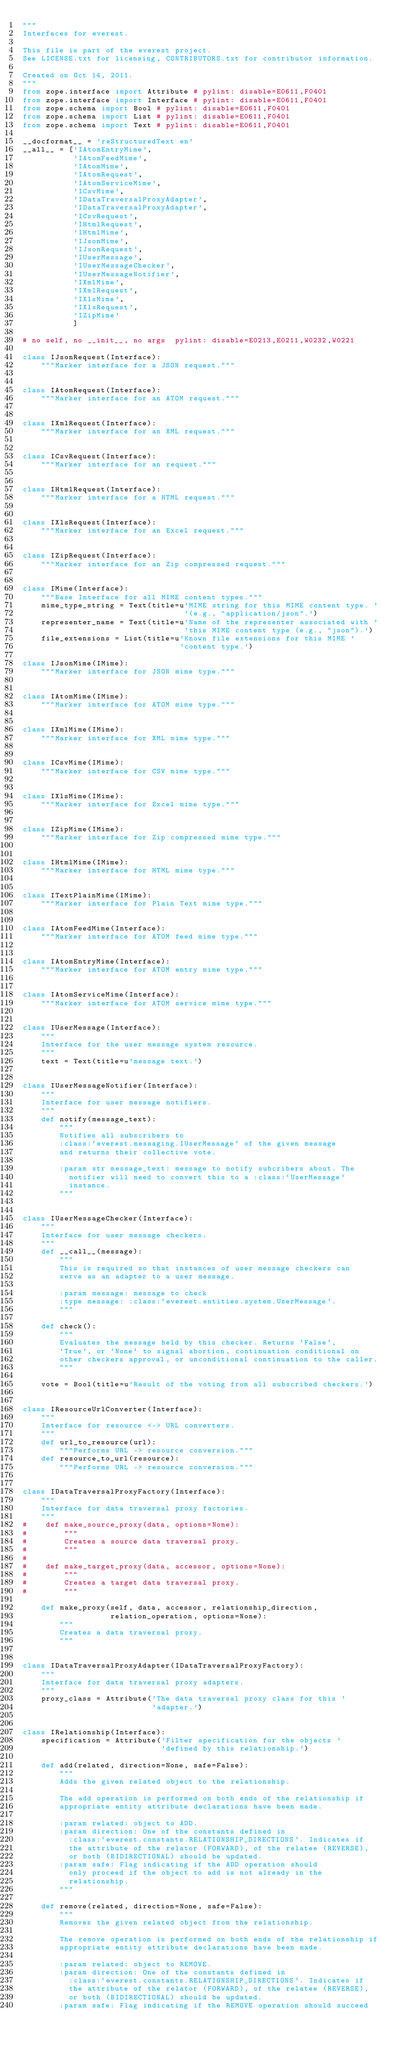<code> <loc_0><loc_0><loc_500><loc_500><_Python_>"""
Interfaces for everest.

This file is part of the everest project.
See LICENSE.txt for licensing, CONTRIBUTORS.txt for contributor information.

Created on Oct 14, 2011.
"""
from zope.interface import Attribute # pylint: disable=E0611,F0401
from zope.interface import Interface # pylint: disable=E0611,F0401
from zope.schema import Bool # pylint: disable=E0611,F0401
from zope.schema import List # pylint: disable=E0611,F0401
from zope.schema import Text # pylint: disable=E0611,F0401

__docformat__ = 'reStructuredText en'
__all__ = ['IAtomEntryMime',
           'IAtomFeedMime',
           'IAtomMime',
           'IAtomRequest',
           'IAtomServiceMime',
           'ICsvMime',
           'IDataTraversalProxyAdapter',
           'IDataTraversalProxyAdapter',
           'ICsvRequest',
           'IHtmlRequest',
           'IHtmlMime',
           'IJsonMime',
           'IJsonRequest',
           'IUserMessage',
           'IUserMessageChecker',
           'IUserMessageNotifier',
           'IXmlMime',
           'IXmlRequest',
           'IXlsMime',
           'IXlsRequest',
           'IZipMime'
           ]

# no self, no __init__, no args  pylint: disable=E0213,E0211,W0232,W0221

class IJsonRequest(Interface):
    """Marker interface for a JSON request."""


class IAtomRequest(Interface):
    """Marker interface for an ATOM request."""


class IXmlRequest(Interface):
    """Marker interface for an XML request."""


class ICsvRequest(Interface):
    """Marker interface for an request."""


class IHtmlRequest(Interface):
    """Marker interface for a HTML request."""


class IXlsRequest(Interface):
    """Marker interface for an Excel request."""


class IZipRequest(Interface):
    """Marker interface for an Zip compressed request."""


class IMime(Interface):
    """Base Interface for all MIME content types."""
    mime_type_string = Text(title=u'MIME string for this MIME content type. '
                                   '(e.g., "application/json".')
    representer_name = Text(title=u'Name of the representer associated with '
                                   'this MIME content type (e.g., "json").')
    file_extensions = List(title=u'Known file extensions for this MIME '
                                  'content type.')

class IJsonMime(IMime):
    """Marker interface for JSON mime type."""


class IAtomMime(IMime):
    """Marker interface for ATOM mime type."""


class IXmlMime(IMime):
    """Marker interface for XML mime type."""


class ICsvMime(IMime):
    """Marker interface for CSV mime type."""


class IXlsMime(IMime):
    """Marker interface for Excel mime type."""


class IZipMime(IMime):
    """Marker interface for Zip compressed mime type."""


class IHtmlMime(IMime):
    """Marker interface for HTML mime type."""


class ITextPlainMime(IMime):
    """Marker interface for Plain Text mime type."""


class IAtomFeedMime(Interface):
    """Marker interface for ATOM feed mime type."""


class IAtomEntryMime(Interface):
    """Marker interface for ATOM entry mime type."""


class IAtomServiceMime(Interface):
    """Marker interface for ATOM service mime type."""


class IUserMessage(Interface):
    """
    Interface for the user message system resource.
    """
    text = Text(title=u'message text.')


class IUserMessageNotifier(Interface):
    """
    Interface for user message notifiers.
    """
    def notify(message_text):
        """
        Notifies all subscribers to
        :class:`everest.messaging.IUserMessage` of the given message
        and returns their collective vote.

        :param str message_text: message to notify subcribers about. The
          notifier will need to convert this to a :class:`UserMessage`
          instance.
        """


class IUserMessageChecker(Interface):
    """
    Interface for user message checkers.
    """
    def __call__(message):
        """
        This is required so that instances of user message checkers can
        serve as an adapter to a user message.

        :param message: message to check
        :type message: :class:`everest.entities.system.UserMessage`.
        """

    def check():
        """
        Evaluates the message held by this checker. Returns `False`,
        `True`, or `None` to signal abortion, continuation conditional on
        other checkers approval, or unconditional continuation to the caller.
        """

    vote = Bool(title=u'Result of the voting from all subscribed checkers.')


class IResourceUrlConverter(Interface):
    """
    Interface for resource <-> URL converters.
    """
    def url_to_resource(url):
        """Performs URL -> resource conversion."""
    def resource_to_url(resource):
        """Performs URL -> resource conversion."""


class IDataTraversalProxyFactory(Interface):
    """
    Interface for data traversal proxy factories.
    """
#    def make_source_proxy(data, options=None):
#        """
#        Creates a source data traversal proxy.
#        """
#
#    def make_target_proxy(data, accessor, options=None):
#        """
#        Creates a target data traversal proxy.
#        """

    def make_proxy(self, data, accessor, relationship_direction,
                   relation_operation, options=None):
        """
        Creates a data traversal proxy.
        """


class IDataTraversalProxyAdapter(IDataTraversalProxyFactory):
    """
    Interface for data traversal proxy adapters.
    """
    proxy_class = Attribute('The data traversal proxy class for this '
                            'adapter.')


class IRelationship(Interface):
    specification = Attribute('Filter specification for the objects '
                              'defined by this relationship.')

    def add(related, direction=None, safe=False):
        """
        Adds the given related object to the relationship.

        The add operation is performed on both ends of the relationship if
        appropriate entity attribute declarations have been made.

        :param related: object to ADD.
        :param direction: One of the constants defined in
          :class:`everest.constants.RELATIONSHIP_DIRECTIONS`. Indicates if
          the attribute of the relator (FORWARD), of the relatee (REVERSE),
          or both (BIDIRECTIONAL) should be updated.
        :param safe: Flag indicating if the ADD operation should
          only proceed if the object to add is not already in the
          relationship.
        """

    def remove(related, direction=None, safe=False):
        """
        Removes the given related object from the relationship.

        The remove operation is performed on both ends of the relationship if
        appropriate entity attribute declarations have been made.

        :param related: object to REMOVE.
        :param direction: One of the constants defined in
          :class:`everest.constants.RELATIONSHIP_DIRECTIONS`. Indicates if
          the attribute of the relator (FORWARD), of the relatee (REVERSE),
          or both (BIDIRECTIONAL) should be updated.
        :param safe: Flag indicating if the REMOVE operation should succeed</code> 